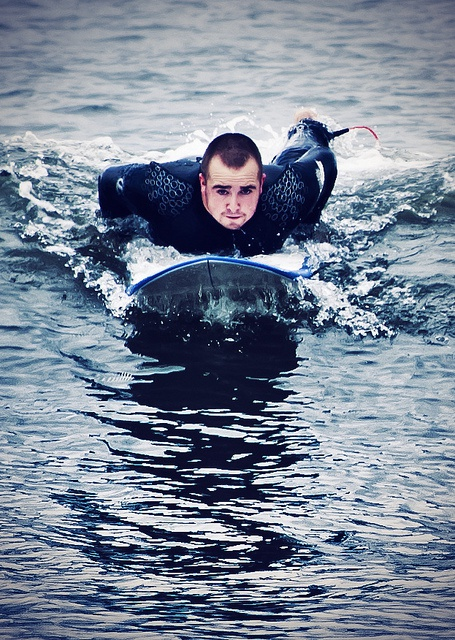Describe the objects in this image and their specific colors. I can see people in gray, black, navy, lightpink, and lightgray tones and surfboard in gray, navy, black, blue, and white tones in this image. 